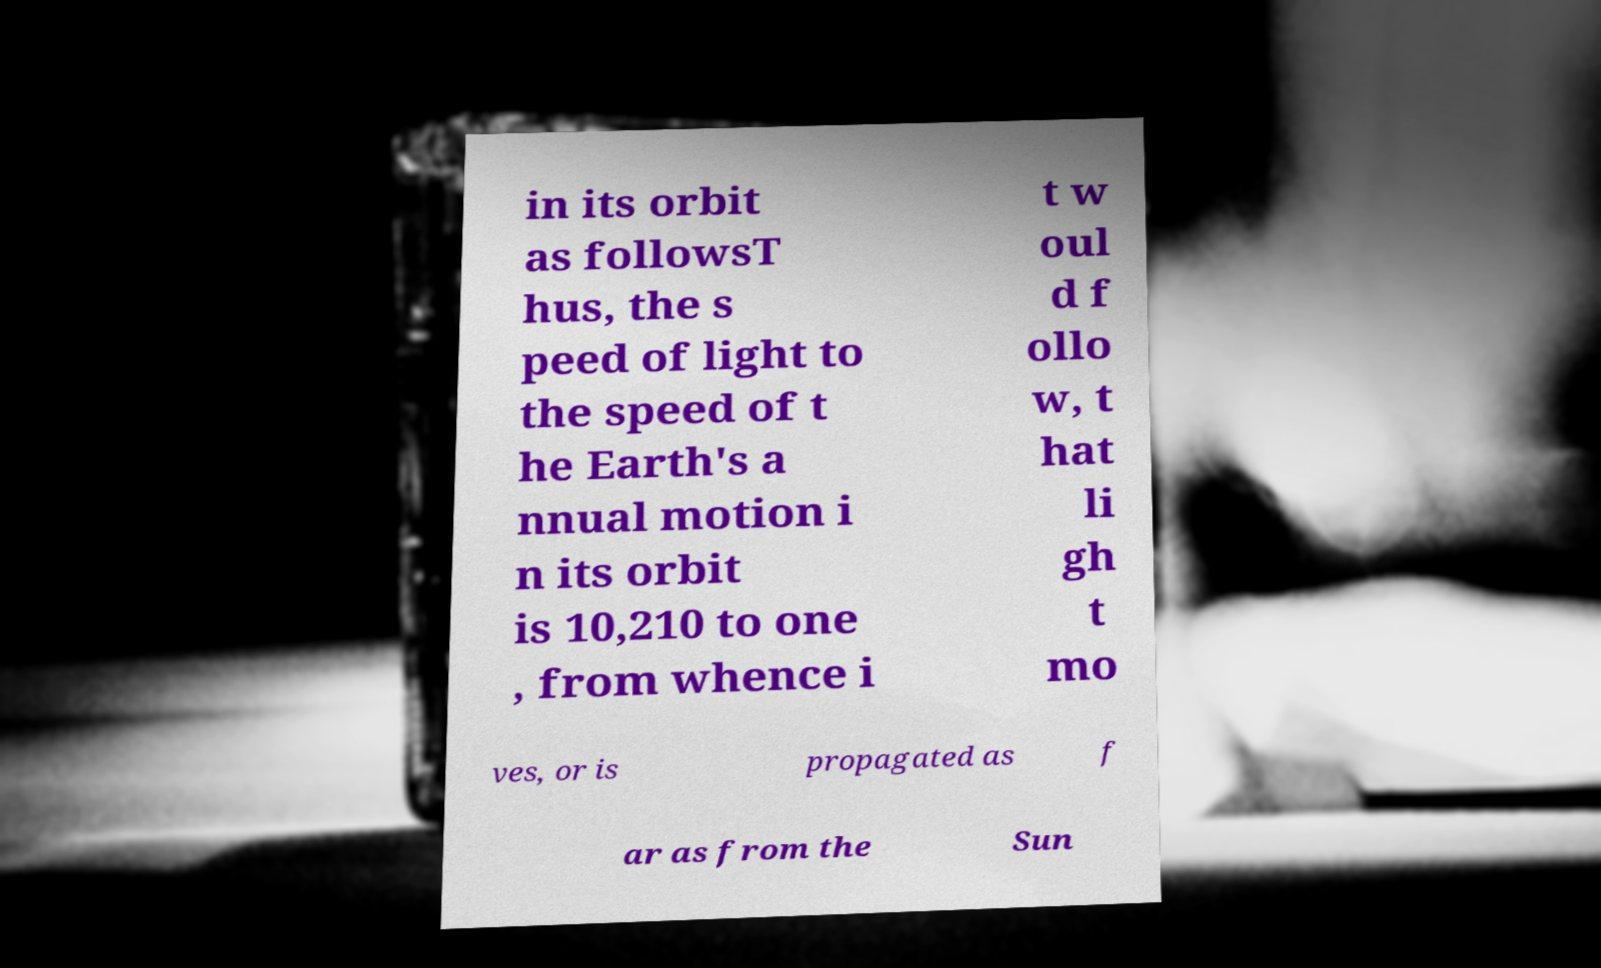Can you read and provide the text displayed in the image?This photo seems to have some interesting text. Can you extract and type it out for me? in its orbit as followsT hus, the s peed of light to the speed of t he Earth's a nnual motion i n its orbit is 10,210 to one , from whence i t w oul d f ollo w, t hat li gh t mo ves, or is propagated as f ar as from the Sun 